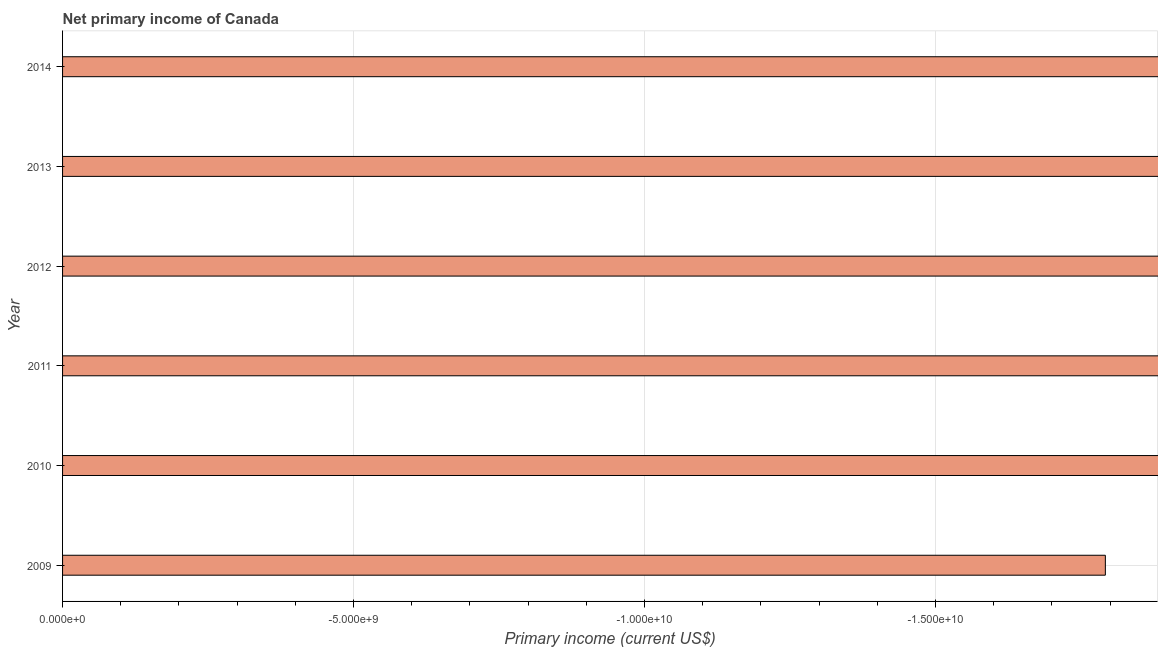Does the graph contain any zero values?
Make the answer very short. Yes. Does the graph contain grids?
Make the answer very short. Yes. What is the title of the graph?
Your answer should be very brief. Net primary income of Canada. What is the label or title of the X-axis?
Offer a terse response. Primary income (current US$). What is the amount of primary income in 2012?
Provide a succinct answer. 0. Across all years, what is the minimum amount of primary income?
Make the answer very short. 0. What is the sum of the amount of primary income?
Offer a very short reply. 0. Are all the bars in the graph horizontal?
Provide a succinct answer. Yes. How many years are there in the graph?
Provide a short and direct response. 6. Are the values on the major ticks of X-axis written in scientific E-notation?
Give a very brief answer. Yes. What is the Primary income (current US$) in 2009?
Your answer should be compact. 0. What is the Primary income (current US$) in 2011?
Your response must be concise. 0. What is the Primary income (current US$) of 2013?
Provide a succinct answer. 0. 